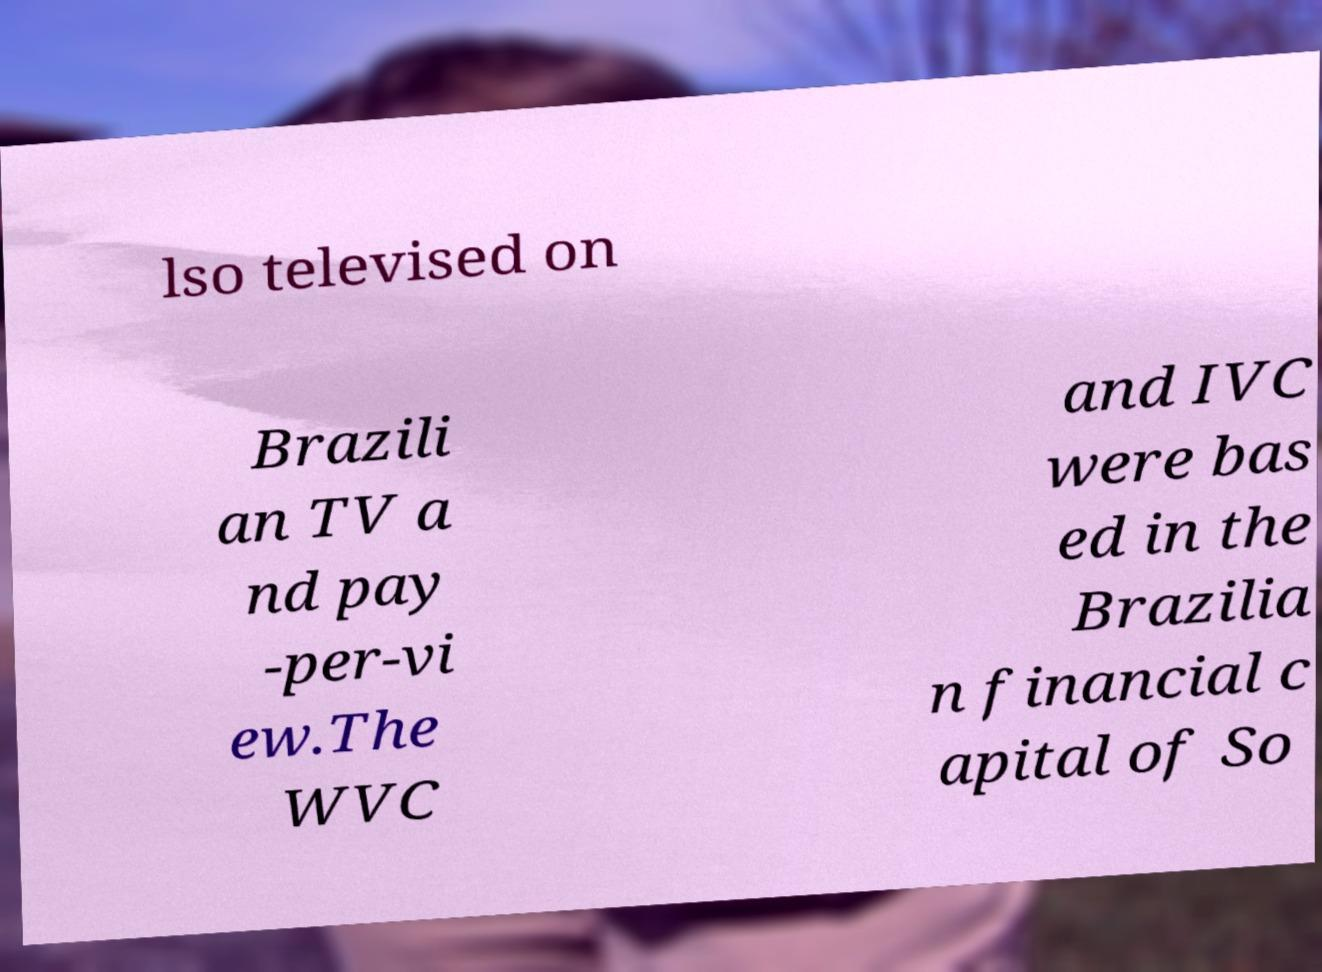What messages or text are displayed in this image? I need them in a readable, typed format. lso televised on Brazili an TV a nd pay -per-vi ew.The WVC and IVC were bas ed in the Brazilia n financial c apital of So 